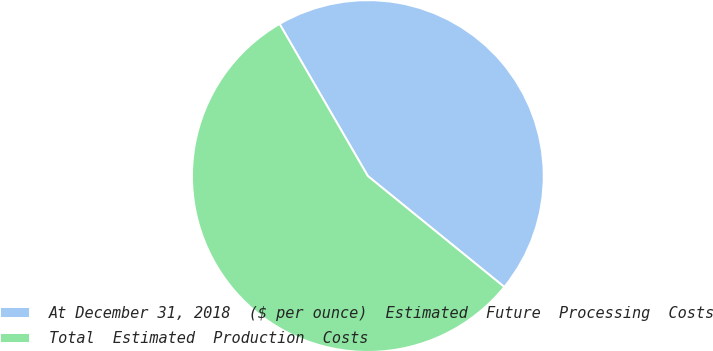Convert chart. <chart><loc_0><loc_0><loc_500><loc_500><pie_chart><fcel>At December 31, 2018  ($ per ounce)  Estimated  Future  Processing  Costs<fcel>Total  Estimated  Production  Costs<nl><fcel>44.23%<fcel>55.77%<nl></chart> 